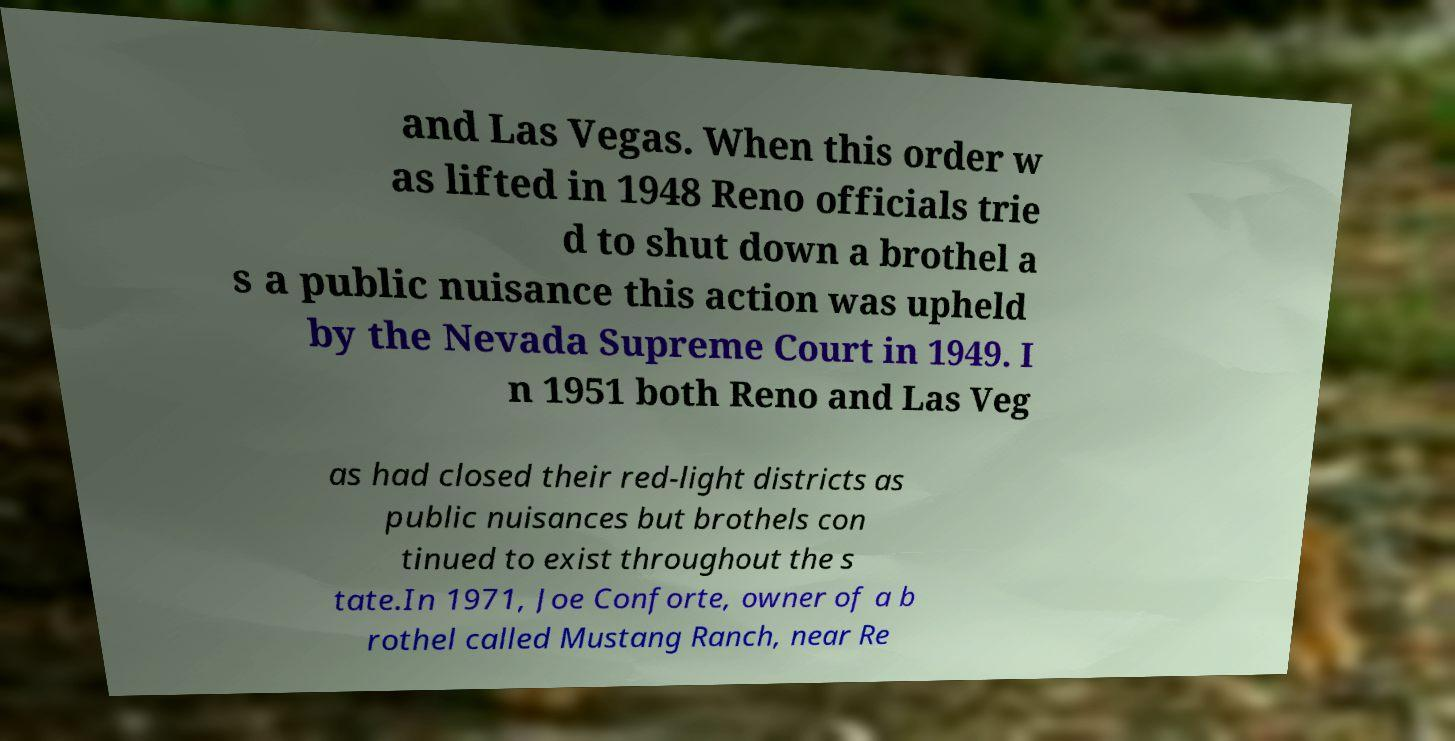I need the written content from this picture converted into text. Can you do that? and Las Vegas. When this order w as lifted in 1948 Reno officials trie d to shut down a brothel a s a public nuisance this action was upheld by the Nevada Supreme Court in 1949. I n 1951 both Reno and Las Veg as had closed their red-light districts as public nuisances but brothels con tinued to exist throughout the s tate.In 1971, Joe Conforte, owner of a b rothel called Mustang Ranch, near Re 